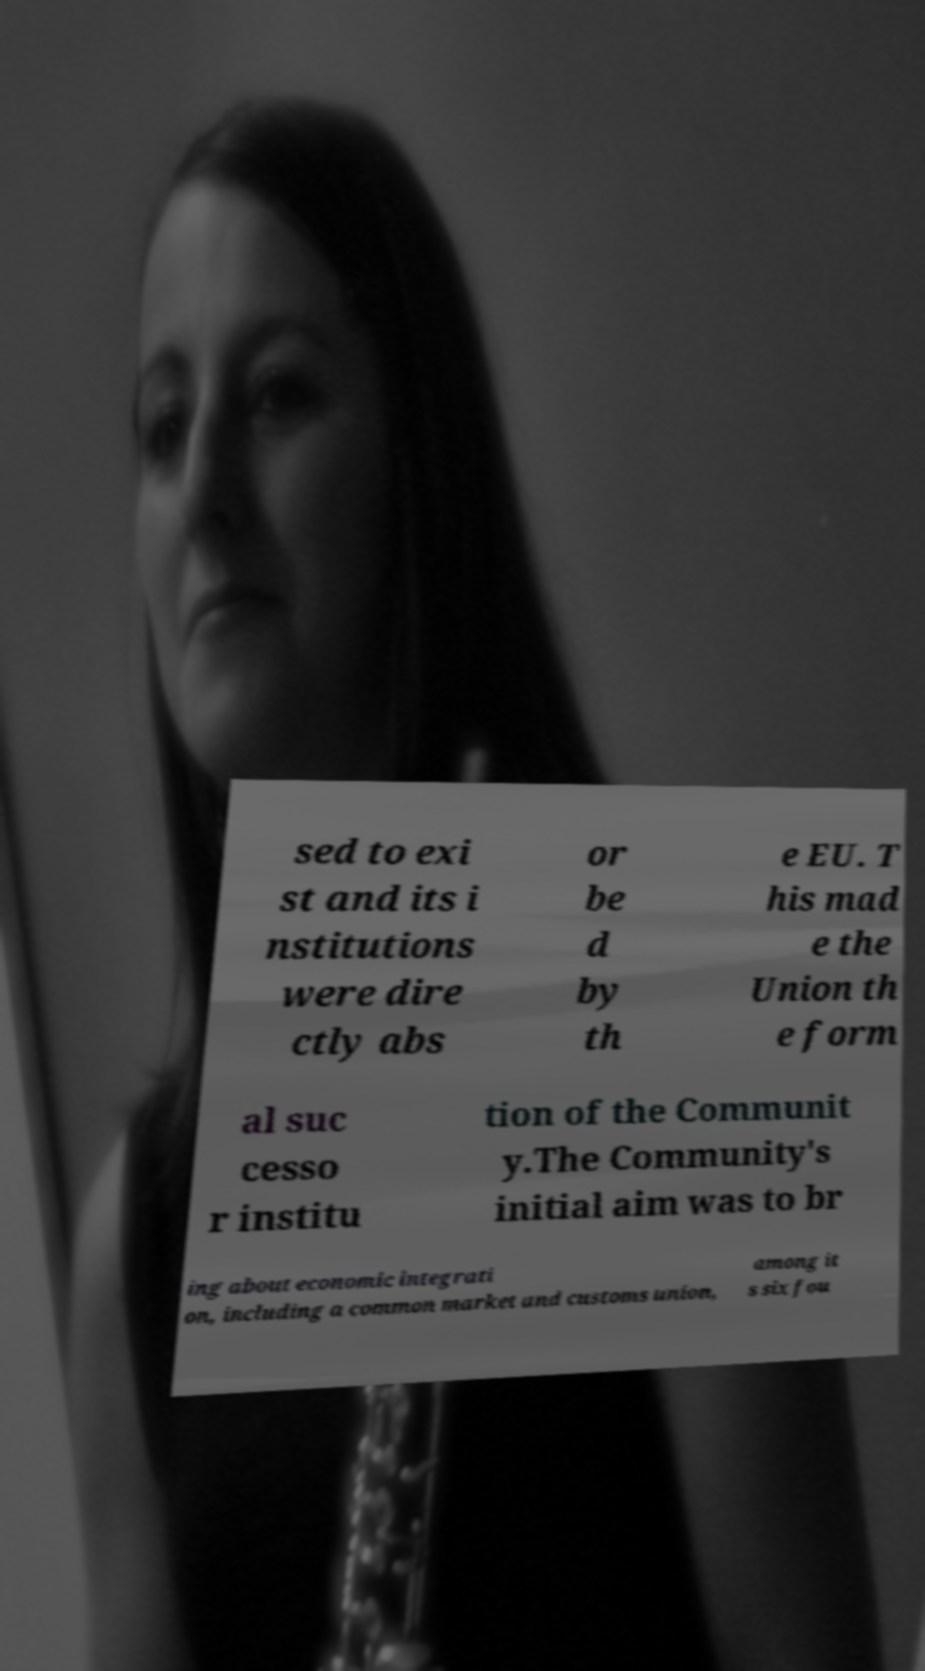There's text embedded in this image that I need extracted. Can you transcribe it verbatim? sed to exi st and its i nstitutions were dire ctly abs or be d by th e EU. T his mad e the Union th e form al suc cesso r institu tion of the Communit y.The Community's initial aim was to br ing about economic integrati on, including a common market and customs union, among it s six fou 